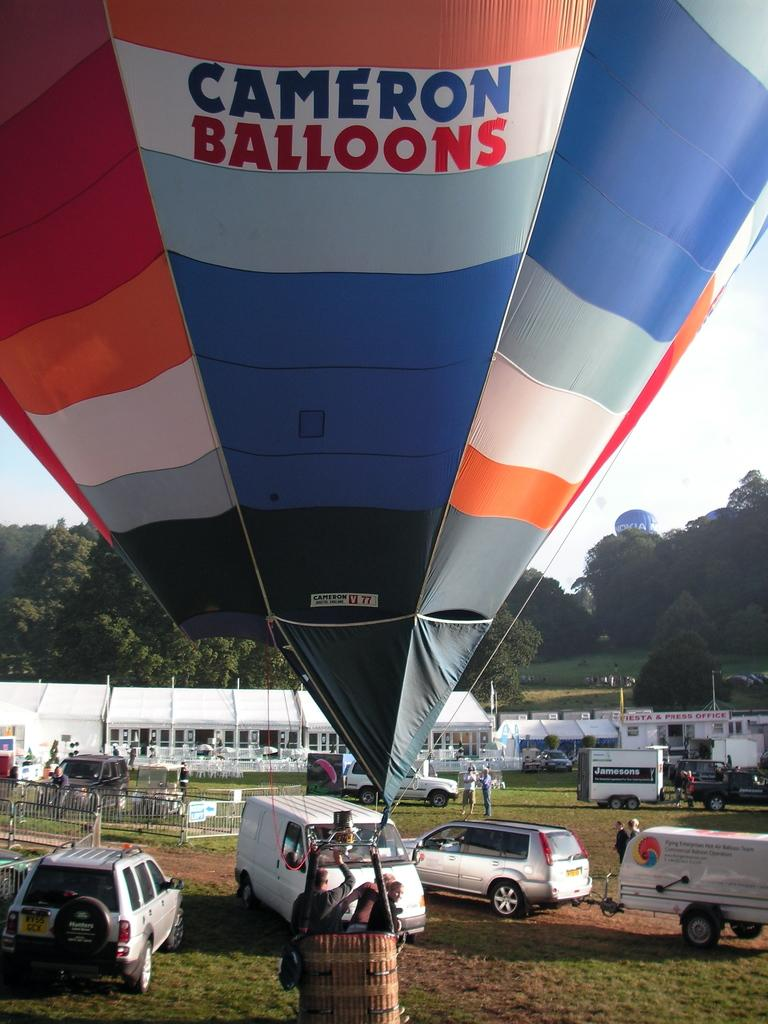Provide a one-sentence caption for the provided image. A big floating balloon with the words Cameron Balloons wrote on it. 